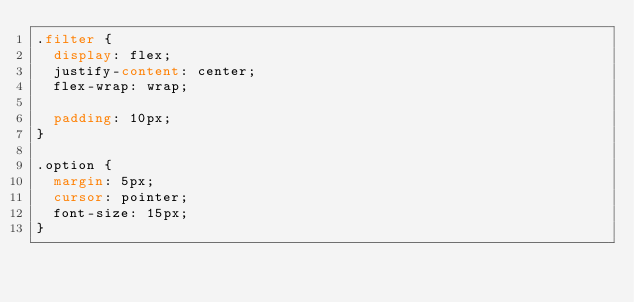<code> <loc_0><loc_0><loc_500><loc_500><_CSS_>.filter {
  display: flex;
  justify-content: center;
  flex-wrap: wrap;

  padding: 10px;
}

.option {
  margin: 5px;
  cursor: pointer;
  font-size: 15px;
}
</code> 